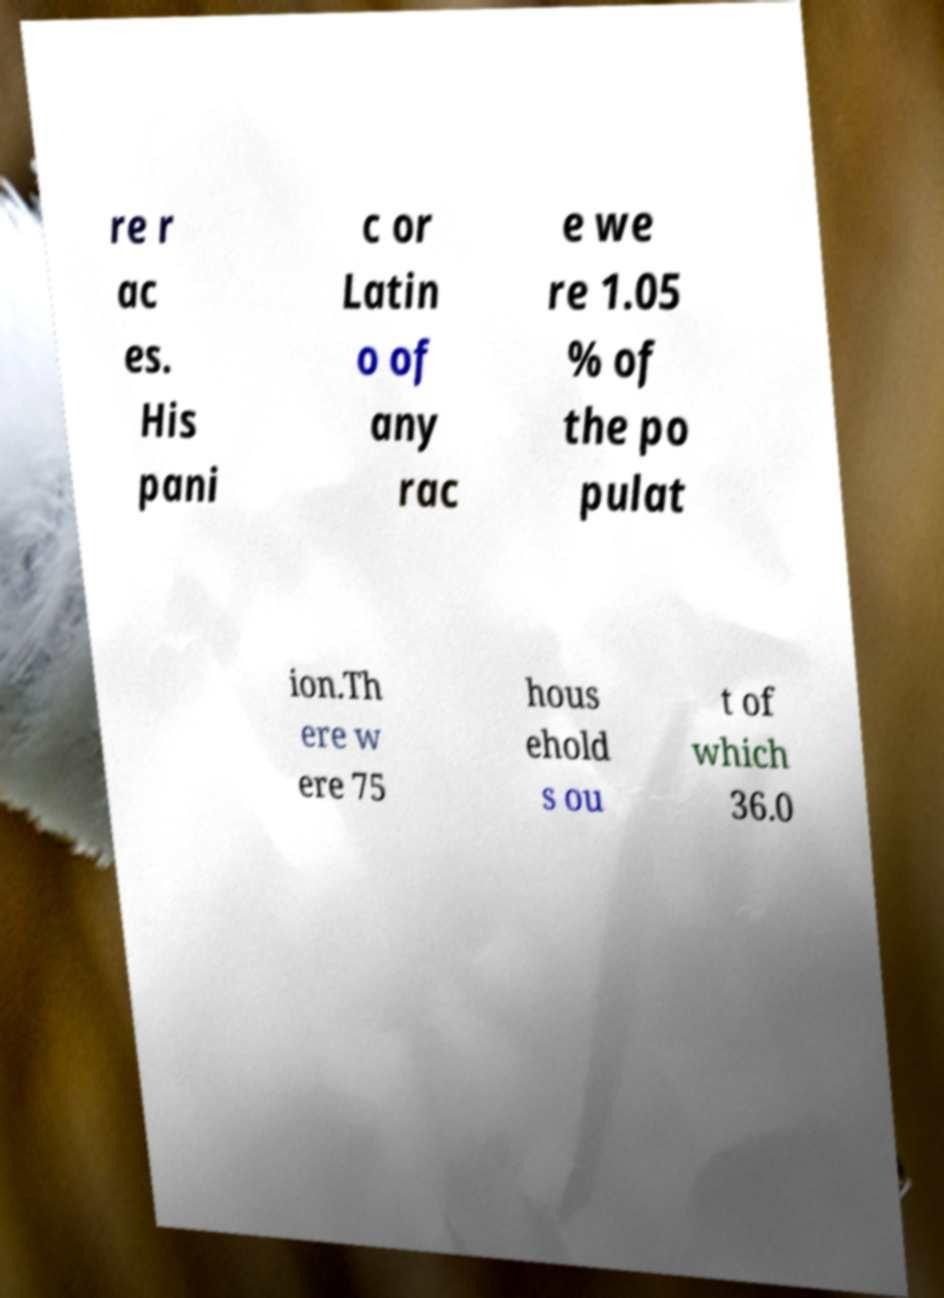Please read and relay the text visible in this image. What does it say? re r ac es. His pani c or Latin o of any rac e we re 1.05 % of the po pulat ion.Th ere w ere 75 hous ehold s ou t of which 36.0 